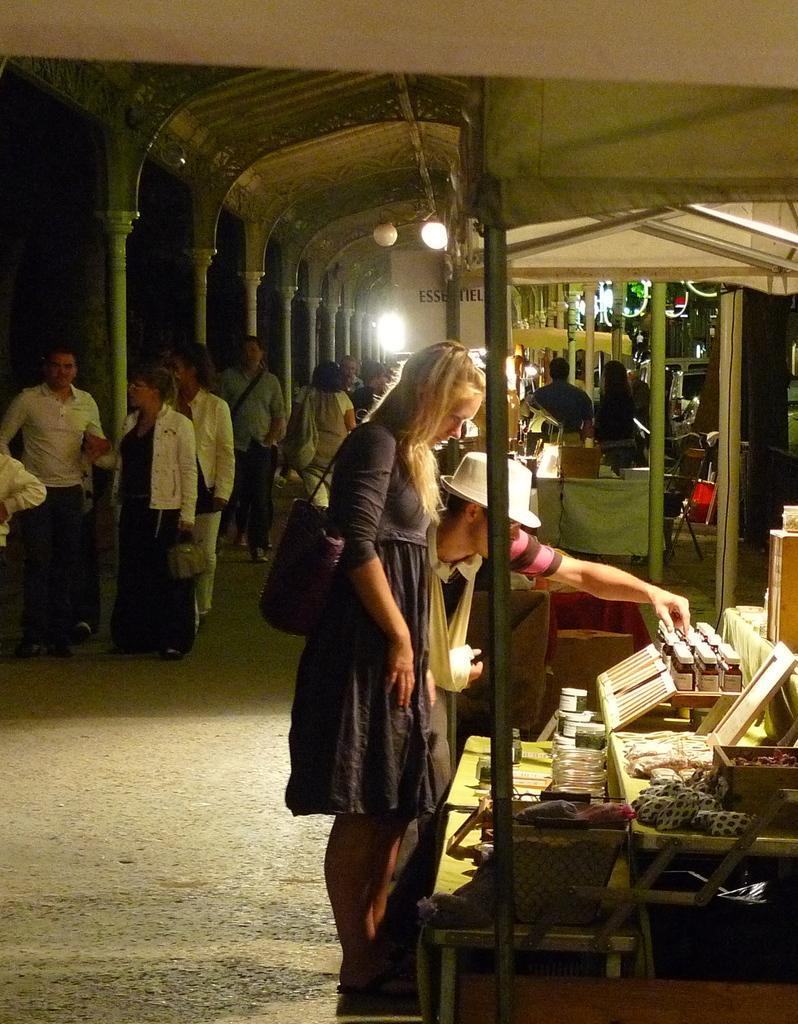Could you give a brief overview of what you see in this image? There is a woman in a dress wearing a hand bag, standing and watching bottles, photo frames and other objects arranged on the shelves near a person who is wearing a white color cap and touching a bottle on the shelf. In the background, there are other persons standing on the road, there is a roof, a light and other objects. And the background is dark in color. 